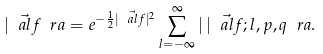<formula> <loc_0><loc_0><loc_500><loc_500>| \vec { \ a l f } \ r a = e ^ { - \frac { 1 } { 2 } | \vec { \ a l f } | ^ { 2 } } \sum _ { l = - \infty } ^ { \infty } | \, | \vec { \ a l f } ; l , p , q \ r a .</formula> 